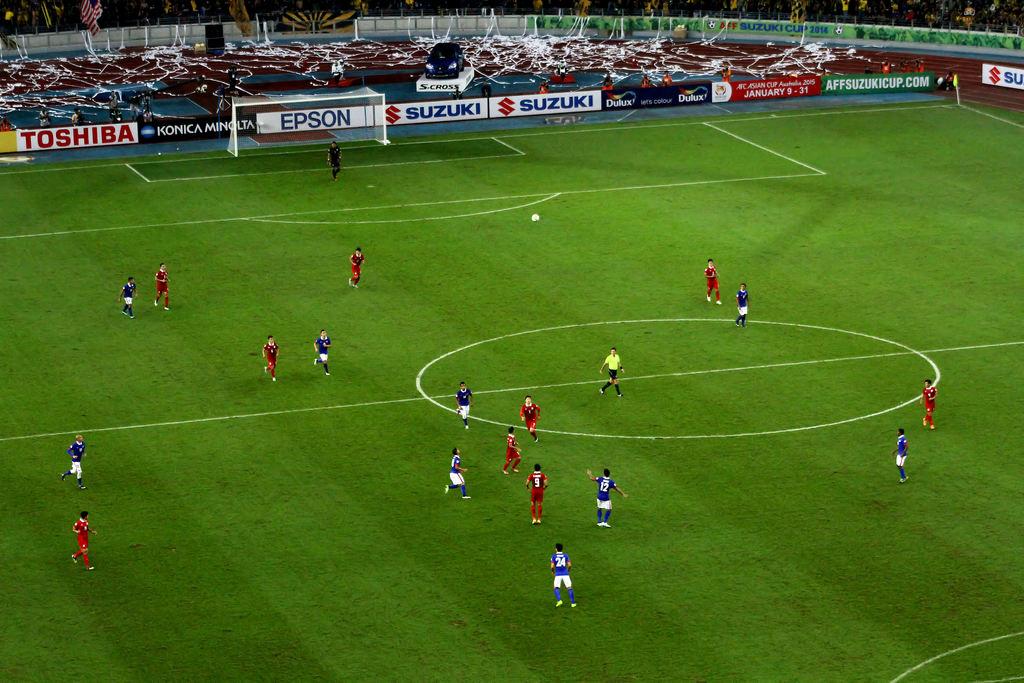What is advertised in the red letters?
Your answer should be very brief. Toshiba. 